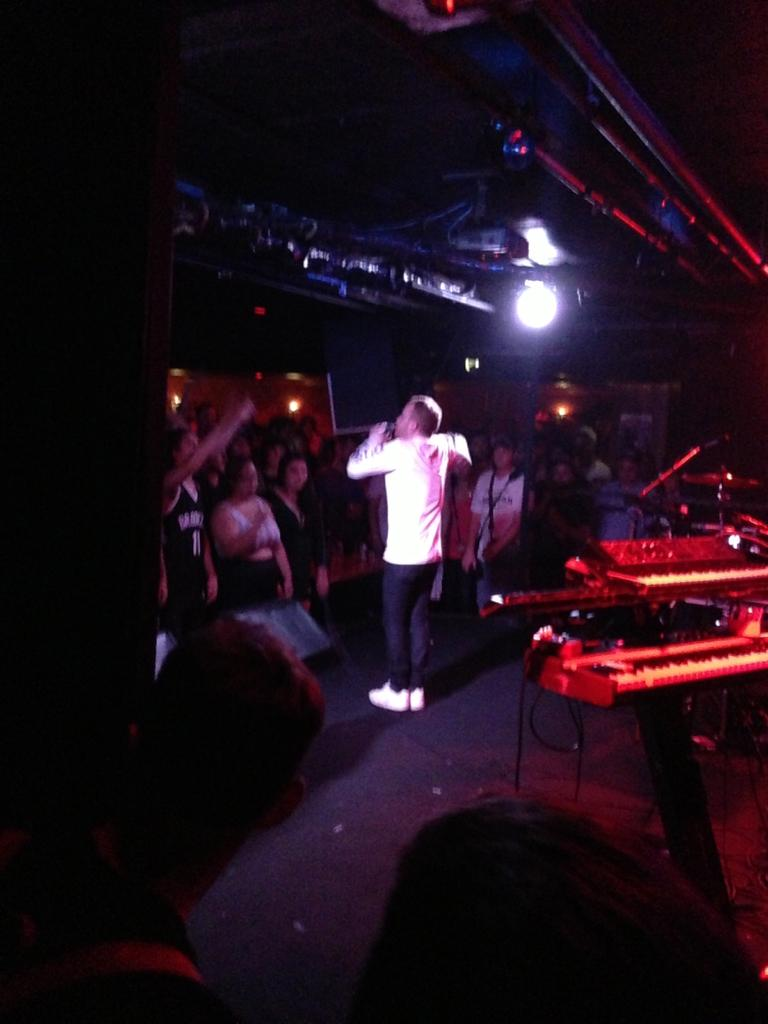Who is the main subject in the image? There is a man in the image. What is the man wearing? The man is wearing a white shirt, trousers, and shoes. What is the man doing in the image? The man is singing. What instrument is visible in the image? There is a piano on the right side of the image. What can be seen in the background of the image? There are people and light visible in the background of the image. What type of smell can be detected in the image? There is no information about any smell in the image, so it cannot be determined. --- Facts: 1. There is a car in the image. 2. The car is red. 3. The car has four wheels. 4. There are people in the car. 5. The car is parked on the street. 6. There are trees on the street. Absurd Topics: bird, ocean, mountain Conversation: What is the main subject in the image? There is a car in the image. What color is the car? The car is red. How many wheels does the car have? The car has four wheels. Who is inside the car? There are people in the car. Where is the car located? The car is parked on the street. What can be seen on the street? There are trees on the street. Reasoning: Let's think step by step in order to produce the conversation. We start by identifying the main subject in the image, which is the car. Then, we describe its color and the number of wheels. Next, we mention the presence of people inside the car and the location of the car on the street. Finally, we describe the street's environment, which includes trees. Each question is designed to elicit a specific detail about the image that is known from the provided facts. Absurd Question/Answer: Can you see any mountains in the image? There is no mention of mountains in the image; it only features a car, people, and trees on the street. 